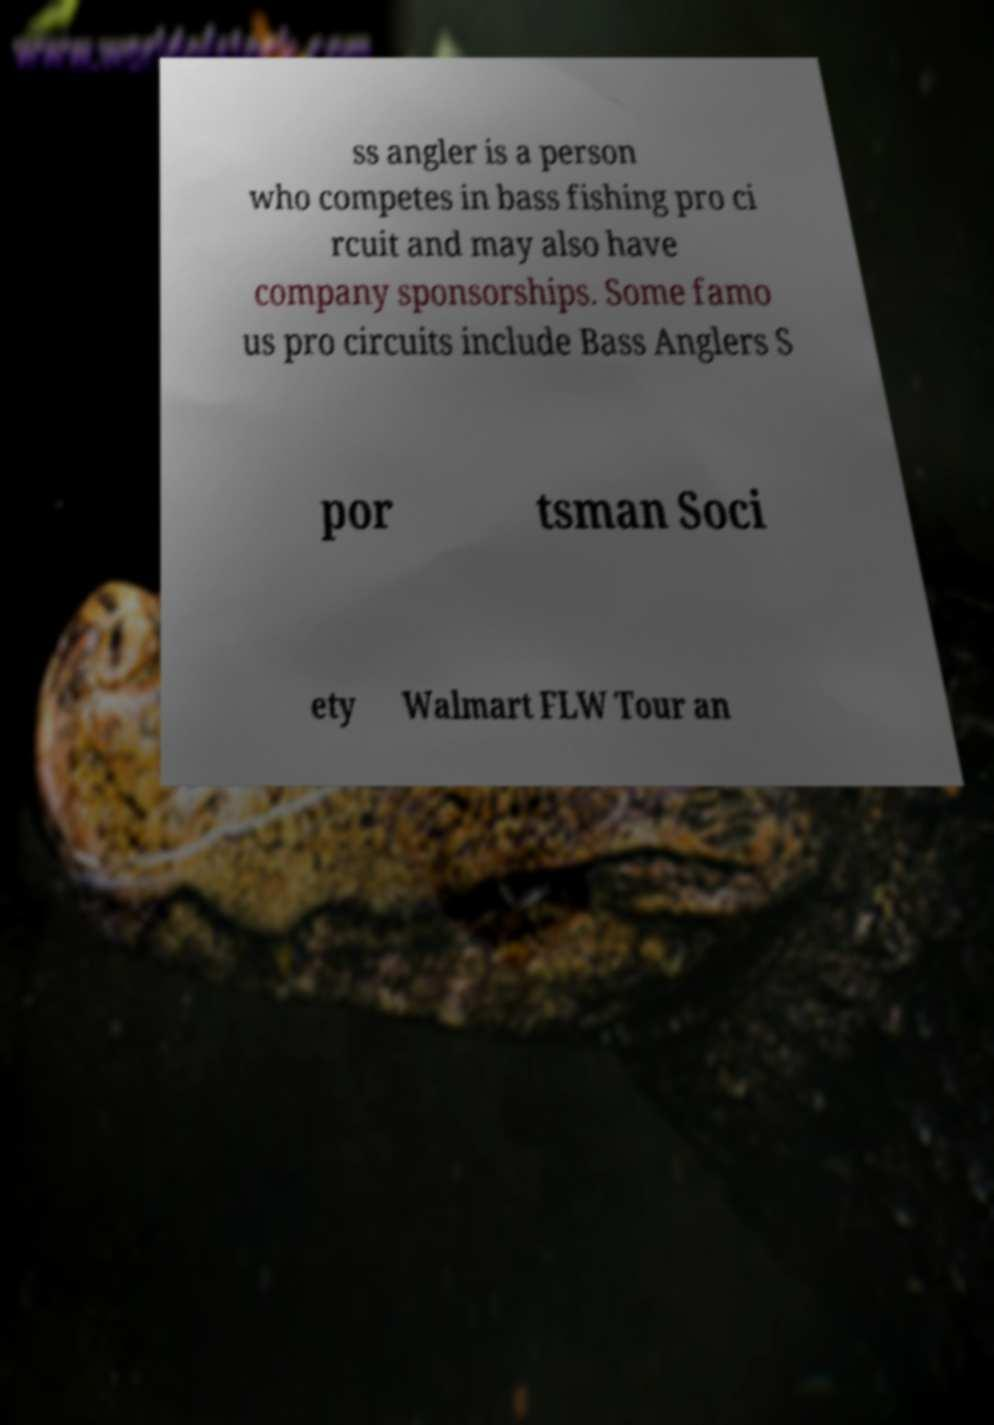Can you accurately transcribe the text from the provided image for me? ss angler is a person who competes in bass fishing pro ci rcuit and may also have company sponsorships. Some famo us pro circuits include Bass Anglers S por tsman Soci ety Walmart FLW Tour an 